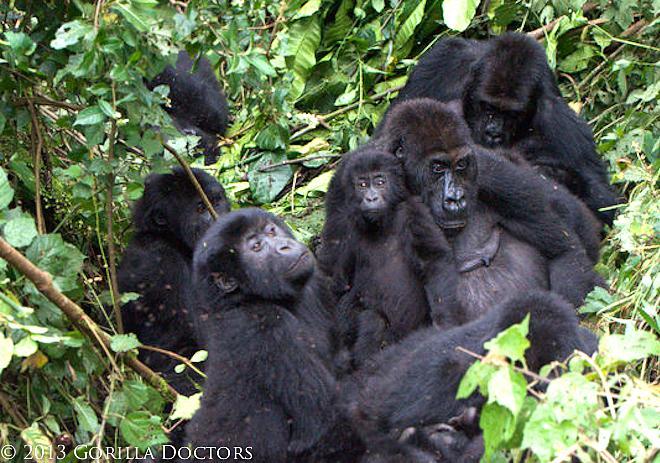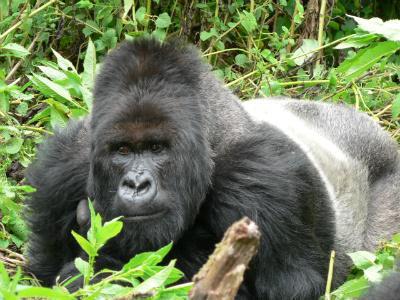The first image is the image on the left, the second image is the image on the right. For the images displayed, is the sentence "There are more than three apes visible, whether in foreground or background." factually correct? Answer yes or no. Yes. The first image is the image on the left, the second image is the image on the right. Assess this claim about the two images: "There are exactly three gorillas in the pair of images.". Correct or not? Answer yes or no. No. 